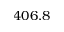Convert formula to latex. <formula><loc_0><loc_0><loc_500><loc_500>4 0 6 . 8</formula> 